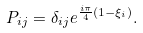<formula> <loc_0><loc_0><loc_500><loc_500>P _ { i j } = \delta _ { i j } e ^ { \frac { i \pi } { 4 } ( 1 - \xi _ { i } ) } .</formula> 